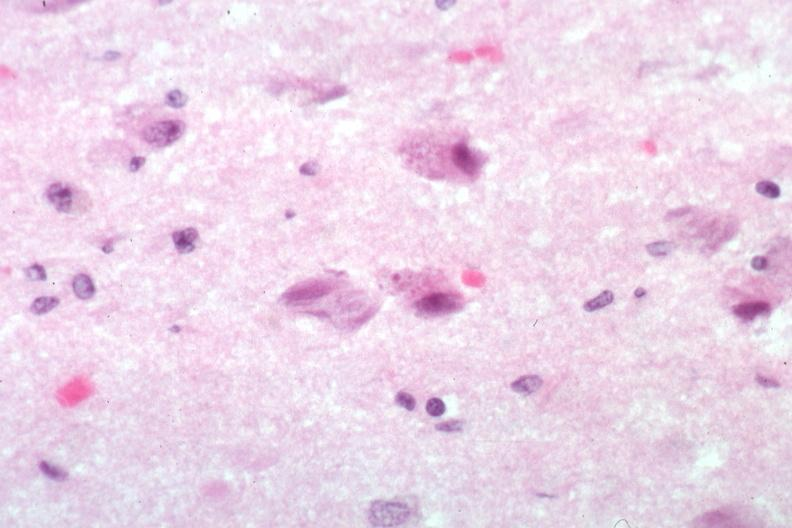what is present?
Answer the question using a single word or phrase. Brain 